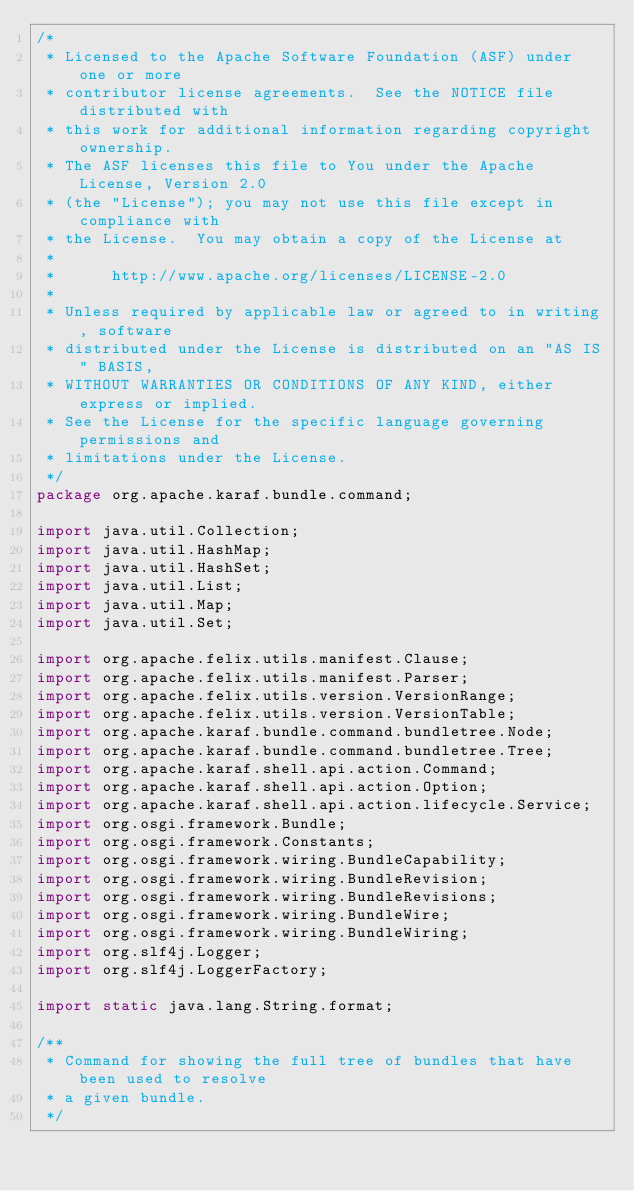<code> <loc_0><loc_0><loc_500><loc_500><_Java_>/*
 * Licensed to the Apache Software Foundation (ASF) under one or more
 * contributor license agreements.  See the NOTICE file distributed with
 * this work for additional information regarding copyright ownership.
 * The ASF licenses this file to You under the Apache License, Version 2.0
 * (the "License"); you may not use this file except in compliance with
 * the License.  You may obtain a copy of the License at
 *
 *      http://www.apache.org/licenses/LICENSE-2.0
 *
 * Unless required by applicable law or agreed to in writing, software
 * distributed under the License is distributed on an "AS IS" BASIS,
 * WITHOUT WARRANTIES OR CONDITIONS OF ANY KIND, either express or implied.
 * See the License for the specific language governing permissions and
 * limitations under the License.
 */
package org.apache.karaf.bundle.command;

import java.util.Collection;
import java.util.HashMap;
import java.util.HashSet;
import java.util.List;
import java.util.Map;
import java.util.Set;

import org.apache.felix.utils.manifest.Clause;
import org.apache.felix.utils.manifest.Parser;
import org.apache.felix.utils.version.VersionRange;
import org.apache.felix.utils.version.VersionTable;
import org.apache.karaf.bundle.command.bundletree.Node;
import org.apache.karaf.bundle.command.bundletree.Tree;
import org.apache.karaf.shell.api.action.Command;
import org.apache.karaf.shell.api.action.Option;
import org.apache.karaf.shell.api.action.lifecycle.Service;
import org.osgi.framework.Bundle;
import org.osgi.framework.Constants;
import org.osgi.framework.wiring.BundleCapability;
import org.osgi.framework.wiring.BundleRevision;
import org.osgi.framework.wiring.BundleRevisions;
import org.osgi.framework.wiring.BundleWire;
import org.osgi.framework.wiring.BundleWiring;
import org.slf4j.Logger;
import org.slf4j.LoggerFactory;

import static java.lang.String.format;

/**
 * Command for showing the full tree of bundles that have been used to resolve
 * a given bundle.
 */</code> 